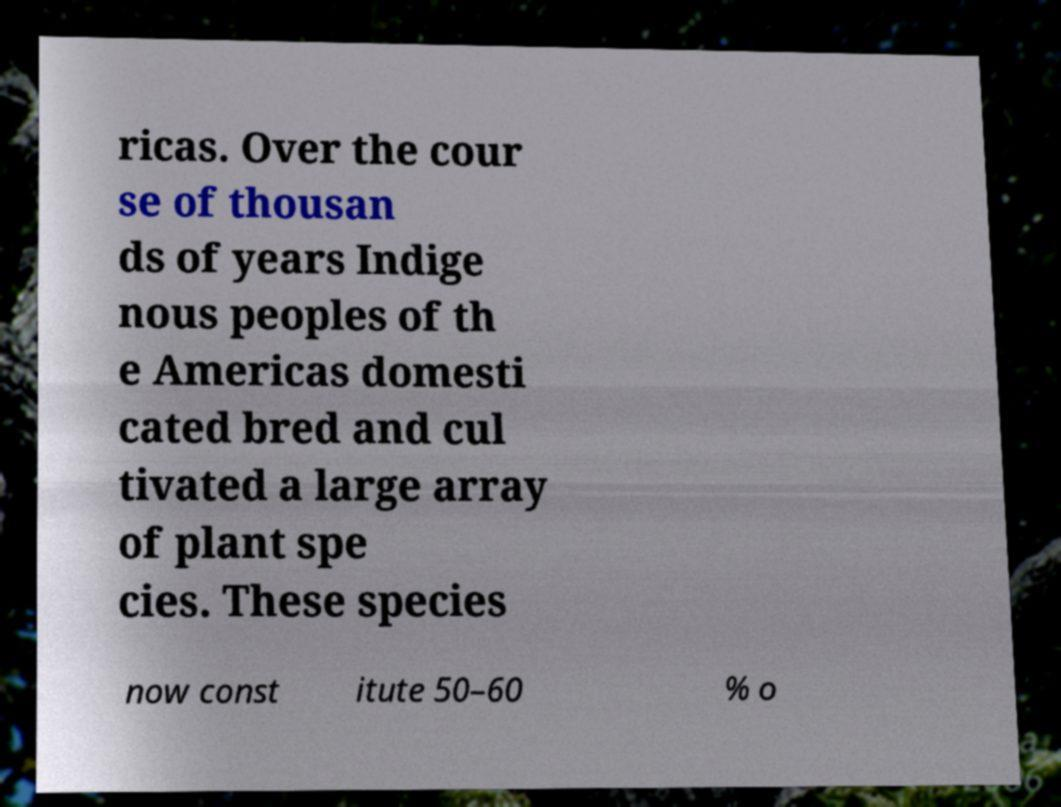Can you read and provide the text displayed in the image?This photo seems to have some interesting text. Can you extract and type it out for me? ricas. Over the cour se of thousan ds of years Indige nous peoples of th e Americas domesti cated bred and cul tivated a large array of plant spe cies. These species now const itute 50–60 % o 